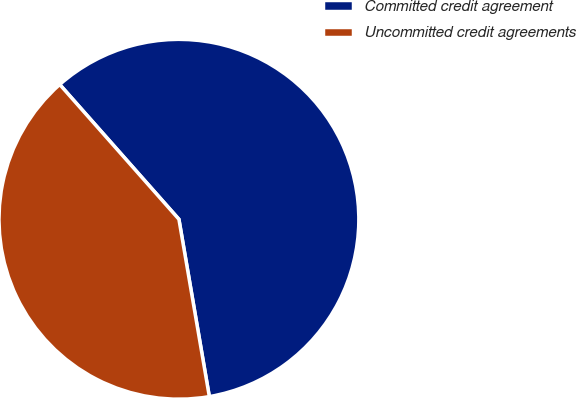Convert chart to OTSL. <chart><loc_0><loc_0><loc_500><loc_500><pie_chart><fcel>Committed credit agreement<fcel>Uncommitted credit agreements<nl><fcel>58.82%<fcel>41.18%<nl></chart> 